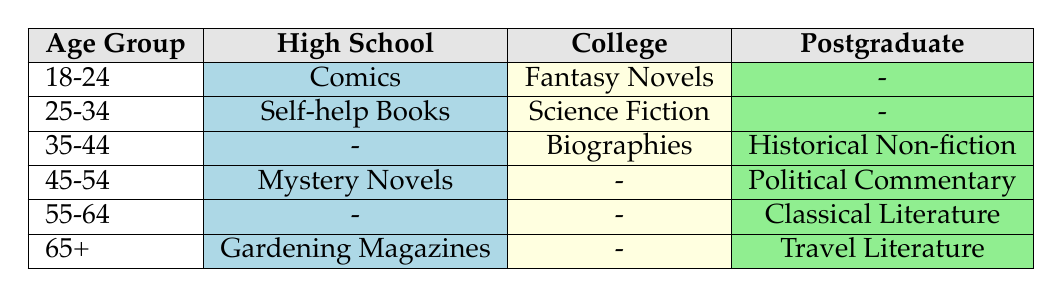What is the preferred reading material for the age group 25-34 with a college education? In the table, we look at the row corresponding to the age group 25-34 and see that under the College column, the preference is Science Fiction.
Answer: Science Fiction Which age group shows a preference for Gardening Magazines? The table indicates that the preference for Gardening Magazines is listed under the age group 65+ alongside the High School column.
Answer: 65+ Are there any preferences listed for the 35-44 age group in the High School category? By examining the row for the 35-44 age group, it shows a dash (-) under the High School column, indicating that there are no recorded preferences.
Answer: No How many age groups have a preference for Mystery Novels? There is one age group, which is 45-54, that has Mystery Novels listed in the High School column.
Answer: 1 Is there a clear preference for reading 'Biographies' among individuals with a college education? The table shows that the preference for Biographies is noted under the College column for the age group 35-44, confirming a preference among that demographic.
Answer: Yes What is the total number of reading preferences listed for the age group 18-24? From the table, the age group 18-24 has one preference each for High School (Comics) and College (Fantasy Novels), totaling two preferences for that age group.
Answer: 2 Which educational background shows a consistent preference for classical literature? Upon examining the table, Classical Literature is only associated with the Postgraduate educational background in the 55-64 age group, making it the only background with that preference.
Answer: Postgraduate For people aged 45-54, how many different reading preferences are there across all educational backgrounds? The table indicates there are two preferences: Mystery Novels listed under High School and Political Commentary under Postgraduate, hence there are two different preferences for that age group.
Answer: 2 Is there any reading material indicated for individuals aged 55-64 with a High School education? The table reveals that there is a dash (-) for the 55-64 age group under the High School category, indicating no preference.
Answer: No 